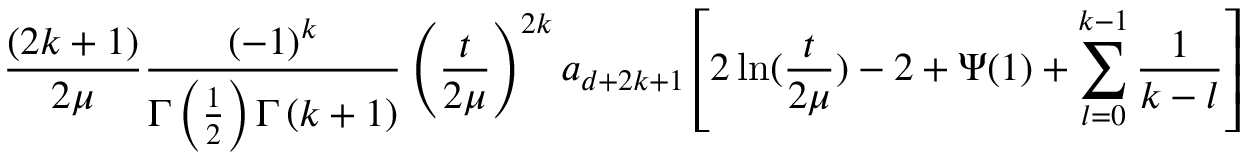Convert formula to latex. <formula><loc_0><loc_0><loc_500><loc_500>\frac { ( 2 k + 1 ) } { 2 \mu } \frac { \left ( - 1 \right ) ^ { k } } { \Gamma \left ( \frac { 1 } { 2 } \right ) \Gamma \left ( k + 1 \right ) } \left ( \frac { t } { 2 \mu } \right ) ^ { 2 k } a _ { d + 2 k + 1 } \left [ 2 \ln ( \frac { t } { 2 \mu } ) - 2 + \Psi ( 1 ) + \sum _ { l = 0 } ^ { k - 1 } \frac { 1 } k - l } \right ]</formula> 